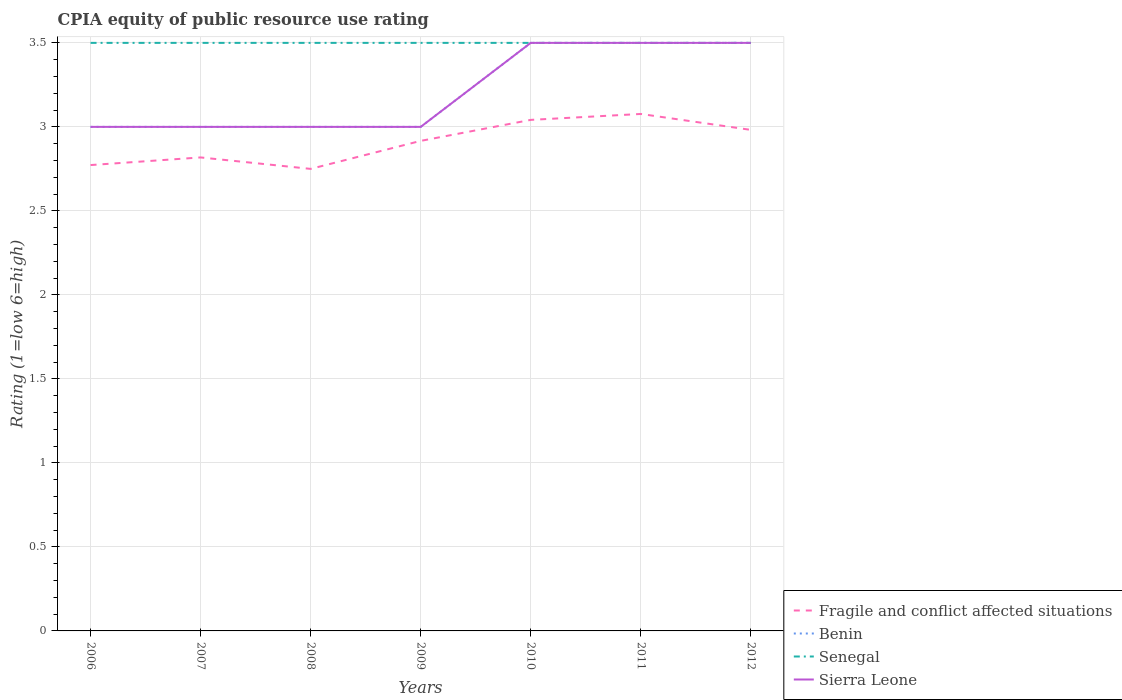Does the line corresponding to Sierra Leone intersect with the line corresponding to Senegal?
Your answer should be compact. Yes. What is the total CPIA rating in Fragile and conflict affected situations in the graph?
Keep it short and to the point. -0.27. What is the difference between the highest and the lowest CPIA rating in Senegal?
Provide a succinct answer. 0. Is the CPIA rating in Fragile and conflict affected situations strictly greater than the CPIA rating in Senegal over the years?
Give a very brief answer. Yes. How many lines are there?
Keep it short and to the point. 4. How many years are there in the graph?
Provide a succinct answer. 7. Are the values on the major ticks of Y-axis written in scientific E-notation?
Your response must be concise. No. Where does the legend appear in the graph?
Keep it short and to the point. Bottom right. How many legend labels are there?
Your answer should be compact. 4. How are the legend labels stacked?
Your answer should be very brief. Vertical. What is the title of the graph?
Ensure brevity in your answer.  CPIA equity of public resource use rating. What is the Rating (1=low 6=high) of Fragile and conflict affected situations in 2006?
Make the answer very short. 2.77. What is the Rating (1=low 6=high) in Benin in 2006?
Offer a terse response. 3. What is the Rating (1=low 6=high) in Sierra Leone in 2006?
Provide a succinct answer. 3. What is the Rating (1=low 6=high) of Fragile and conflict affected situations in 2007?
Keep it short and to the point. 2.82. What is the Rating (1=low 6=high) of Fragile and conflict affected situations in 2008?
Provide a succinct answer. 2.75. What is the Rating (1=low 6=high) in Benin in 2008?
Offer a very short reply. 3. What is the Rating (1=low 6=high) in Senegal in 2008?
Your answer should be very brief. 3.5. What is the Rating (1=low 6=high) in Sierra Leone in 2008?
Offer a terse response. 3. What is the Rating (1=low 6=high) in Fragile and conflict affected situations in 2009?
Provide a succinct answer. 2.92. What is the Rating (1=low 6=high) in Benin in 2009?
Your response must be concise. 3. What is the Rating (1=low 6=high) in Senegal in 2009?
Give a very brief answer. 3.5. What is the Rating (1=low 6=high) of Fragile and conflict affected situations in 2010?
Give a very brief answer. 3.04. What is the Rating (1=low 6=high) in Benin in 2010?
Give a very brief answer. 3.5. What is the Rating (1=low 6=high) of Senegal in 2010?
Your response must be concise. 3.5. What is the Rating (1=low 6=high) in Sierra Leone in 2010?
Provide a short and direct response. 3.5. What is the Rating (1=low 6=high) in Fragile and conflict affected situations in 2011?
Ensure brevity in your answer.  3.08. What is the Rating (1=low 6=high) of Benin in 2011?
Provide a succinct answer. 3.5. What is the Rating (1=low 6=high) in Senegal in 2011?
Keep it short and to the point. 3.5. What is the Rating (1=low 6=high) in Fragile and conflict affected situations in 2012?
Make the answer very short. 2.98. What is the Rating (1=low 6=high) of Benin in 2012?
Keep it short and to the point. 3.5. What is the Rating (1=low 6=high) in Senegal in 2012?
Offer a very short reply. 3.5. What is the Rating (1=low 6=high) in Sierra Leone in 2012?
Provide a short and direct response. 3.5. Across all years, what is the maximum Rating (1=low 6=high) in Fragile and conflict affected situations?
Keep it short and to the point. 3.08. Across all years, what is the maximum Rating (1=low 6=high) in Benin?
Offer a terse response. 3.5. Across all years, what is the maximum Rating (1=low 6=high) of Senegal?
Your answer should be very brief. 3.5. Across all years, what is the maximum Rating (1=low 6=high) in Sierra Leone?
Make the answer very short. 3.5. Across all years, what is the minimum Rating (1=low 6=high) in Fragile and conflict affected situations?
Keep it short and to the point. 2.75. Across all years, what is the minimum Rating (1=low 6=high) of Benin?
Give a very brief answer. 3. What is the total Rating (1=low 6=high) in Fragile and conflict affected situations in the graph?
Your answer should be very brief. 20.36. What is the total Rating (1=low 6=high) of Benin in the graph?
Your answer should be very brief. 22.5. What is the total Rating (1=low 6=high) in Senegal in the graph?
Your answer should be very brief. 24.5. What is the total Rating (1=low 6=high) in Sierra Leone in the graph?
Your response must be concise. 22.5. What is the difference between the Rating (1=low 6=high) in Fragile and conflict affected situations in 2006 and that in 2007?
Keep it short and to the point. -0.05. What is the difference between the Rating (1=low 6=high) of Senegal in 2006 and that in 2007?
Provide a short and direct response. 0. What is the difference between the Rating (1=low 6=high) of Sierra Leone in 2006 and that in 2007?
Ensure brevity in your answer.  0. What is the difference between the Rating (1=low 6=high) in Fragile and conflict affected situations in 2006 and that in 2008?
Your answer should be compact. 0.02. What is the difference between the Rating (1=low 6=high) in Benin in 2006 and that in 2008?
Ensure brevity in your answer.  0. What is the difference between the Rating (1=low 6=high) in Fragile and conflict affected situations in 2006 and that in 2009?
Provide a succinct answer. -0.14. What is the difference between the Rating (1=low 6=high) in Benin in 2006 and that in 2009?
Your answer should be very brief. 0. What is the difference between the Rating (1=low 6=high) of Sierra Leone in 2006 and that in 2009?
Offer a terse response. 0. What is the difference between the Rating (1=low 6=high) of Fragile and conflict affected situations in 2006 and that in 2010?
Your response must be concise. -0.27. What is the difference between the Rating (1=low 6=high) of Benin in 2006 and that in 2010?
Ensure brevity in your answer.  -0.5. What is the difference between the Rating (1=low 6=high) of Sierra Leone in 2006 and that in 2010?
Ensure brevity in your answer.  -0.5. What is the difference between the Rating (1=low 6=high) in Fragile and conflict affected situations in 2006 and that in 2011?
Offer a terse response. -0.3. What is the difference between the Rating (1=low 6=high) in Benin in 2006 and that in 2011?
Offer a very short reply. -0.5. What is the difference between the Rating (1=low 6=high) in Sierra Leone in 2006 and that in 2011?
Your response must be concise. -0.5. What is the difference between the Rating (1=low 6=high) of Fragile and conflict affected situations in 2006 and that in 2012?
Keep it short and to the point. -0.21. What is the difference between the Rating (1=low 6=high) in Benin in 2006 and that in 2012?
Give a very brief answer. -0.5. What is the difference between the Rating (1=low 6=high) in Senegal in 2006 and that in 2012?
Provide a succinct answer. 0. What is the difference between the Rating (1=low 6=high) of Sierra Leone in 2006 and that in 2012?
Provide a succinct answer. -0.5. What is the difference between the Rating (1=low 6=high) in Fragile and conflict affected situations in 2007 and that in 2008?
Your answer should be very brief. 0.07. What is the difference between the Rating (1=low 6=high) in Senegal in 2007 and that in 2008?
Offer a terse response. 0. What is the difference between the Rating (1=low 6=high) in Fragile and conflict affected situations in 2007 and that in 2009?
Ensure brevity in your answer.  -0.1. What is the difference between the Rating (1=low 6=high) of Benin in 2007 and that in 2009?
Keep it short and to the point. 0. What is the difference between the Rating (1=low 6=high) of Fragile and conflict affected situations in 2007 and that in 2010?
Your answer should be compact. -0.22. What is the difference between the Rating (1=low 6=high) of Benin in 2007 and that in 2010?
Your answer should be compact. -0.5. What is the difference between the Rating (1=low 6=high) in Fragile and conflict affected situations in 2007 and that in 2011?
Your answer should be compact. -0.26. What is the difference between the Rating (1=low 6=high) in Benin in 2007 and that in 2011?
Your answer should be very brief. -0.5. What is the difference between the Rating (1=low 6=high) of Sierra Leone in 2007 and that in 2011?
Offer a terse response. -0.5. What is the difference between the Rating (1=low 6=high) in Fragile and conflict affected situations in 2007 and that in 2012?
Your answer should be very brief. -0.16. What is the difference between the Rating (1=low 6=high) in Benin in 2007 and that in 2012?
Provide a succinct answer. -0.5. What is the difference between the Rating (1=low 6=high) of Senegal in 2007 and that in 2012?
Make the answer very short. 0. What is the difference between the Rating (1=low 6=high) of Sierra Leone in 2007 and that in 2012?
Give a very brief answer. -0.5. What is the difference between the Rating (1=low 6=high) of Fragile and conflict affected situations in 2008 and that in 2009?
Keep it short and to the point. -0.17. What is the difference between the Rating (1=low 6=high) of Benin in 2008 and that in 2009?
Your response must be concise. 0. What is the difference between the Rating (1=low 6=high) of Senegal in 2008 and that in 2009?
Your answer should be compact. 0. What is the difference between the Rating (1=low 6=high) of Sierra Leone in 2008 and that in 2009?
Provide a succinct answer. 0. What is the difference between the Rating (1=low 6=high) in Fragile and conflict affected situations in 2008 and that in 2010?
Keep it short and to the point. -0.29. What is the difference between the Rating (1=low 6=high) of Senegal in 2008 and that in 2010?
Offer a terse response. 0. What is the difference between the Rating (1=low 6=high) in Fragile and conflict affected situations in 2008 and that in 2011?
Offer a very short reply. -0.33. What is the difference between the Rating (1=low 6=high) of Benin in 2008 and that in 2011?
Provide a succinct answer. -0.5. What is the difference between the Rating (1=low 6=high) of Fragile and conflict affected situations in 2008 and that in 2012?
Your answer should be compact. -0.23. What is the difference between the Rating (1=low 6=high) of Benin in 2008 and that in 2012?
Make the answer very short. -0.5. What is the difference between the Rating (1=low 6=high) of Senegal in 2008 and that in 2012?
Provide a short and direct response. 0. What is the difference between the Rating (1=low 6=high) in Sierra Leone in 2008 and that in 2012?
Ensure brevity in your answer.  -0.5. What is the difference between the Rating (1=low 6=high) of Fragile and conflict affected situations in 2009 and that in 2010?
Your answer should be compact. -0.12. What is the difference between the Rating (1=low 6=high) of Benin in 2009 and that in 2010?
Provide a short and direct response. -0.5. What is the difference between the Rating (1=low 6=high) of Fragile and conflict affected situations in 2009 and that in 2011?
Ensure brevity in your answer.  -0.16. What is the difference between the Rating (1=low 6=high) in Sierra Leone in 2009 and that in 2011?
Ensure brevity in your answer.  -0.5. What is the difference between the Rating (1=low 6=high) of Fragile and conflict affected situations in 2009 and that in 2012?
Provide a succinct answer. -0.07. What is the difference between the Rating (1=low 6=high) of Benin in 2009 and that in 2012?
Your answer should be compact. -0.5. What is the difference between the Rating (1=low 6=high) of Senegal in 2009 and that in 2012?
Your answer should be very brief. 0. What is the difference between the Rating (1=low 6=high) of Sierra Leone in 2009 and that in 2012?
Ensure brevity in your answer.  -0.5. What is the difference between the Rating (1=low 6=high) of Fragile and conflict affected situations in 2010 and that in 2011?
Offer a terse response. -0.04. What is the difference between the Rating (1=low 6=high) in Benin in 2010 and that in 2011?
Offer a terse response. 0. What is the difference between the Rating (1=low 6=high) of Senegal in 2010 and that in 2011?
Make the answer very short. 0. What is the difference between the Rating (1=low 6=high) of Fragile and conflict affected situations in 2010 and that in 2012?
Your answer should be very brief. 0.06. What is the difference between the Rating (1=low 6=high) in Benin in 2010 and that in 2012?
Offer a very short reply. 0. What is the difference between the Rating (1=low 6=high) in Sierra Leone in 2010 and that in 2012?
Your answer should be very brief. 0. What is the difference between the Rating (1=low 6=high) of Fragile and conflict affected situations in 2011 and that in 2012?
Ensure brevity in your answer.  0.09. What is the difference between the Rating (1=low 6=high) of Benin in 2011 and that in 2012?
Provide a succinct answer. 0. What is the difference between the Rating (1=low 6=high) in Senegal in 2011 and that in 2012?
Make the answer very short. 0. What is the difference between the Rating (1=low 6=high) of Fragile and conflict affected situations in 2006 and the Rating (1=low 6=high) of Benin in 2007?
Keep it short and to the point. -0.23. What is the difference between the Rating (1=low 6=high) of Fragile and conflict affected situations in 2006 and the Rating (1=low 6=high) of Senegal in 2007?
Your response must be concise. -0.73. What is the difference between the Rating (1=low 6=high) of Fragile and conflict affected situations in 2006 and the Rating (1=low 6=high) of Sierra Leone in 2007?
Your response must be concise. -0.23. What is the difference between the Rating (1=low 6=high) of Fragile and conflict affected situations in 2006 and the Rating (1=low 6=high) of Benin in 2008?
Your response must be concise. -0.23. What is the difference between the Rating (1=low 6=high) of Fragile and conflict affected situations in 2006 and the Rating (1=low 6=high) of Senegal in 2008?
Provide a succinct answer. -0.73. What is the difference between the Rating (1=low 6=high) of Fragile and conflict affected situations in 2006 and the Rating (1=low 6=high) of Sierra Leone in 2008?
Offer a very short reply. -0.23. What is the difference between the Rating (1=low 6=high) of Senegal in 2006 and the Rating (1=low 6=high) of Sierra Leone in 2008?
Provide a succinct answer. 0.5. What is the difference between the Rating (1=low 6=high) of Fragile and conflict affected situations in 2006 and the Rating (1=low 6=high) of Benin in 2009?
Your answer should be compact. -0.23. What is the difference between the Rating (1=low 6=high) of Fragile and conflict affected situations in 2006 and the Rating (1=low 6=high) of Senegal in 2009?
Your answer should be compact. -0.73. What is the difference between the Rating (1=low 6=high) of Fragile and conflict affected situations in 2006 and the Rating (1=low 6=high) of Sierra Leone in 2009?
Your response must be concise. -0.23. What is the difference between the Rating (1=low 6=high) in Senegal in 2006 and the Rating (1=low 6=high) in Sierra Leone in 2009?
Provide a short and direct response. 0.5. What is the difference between the Rating (1=low 6=high) in Fragile and conflict affected situations in 2006 and the Rating (1=low 6=high) in Benin in 2010?
Provide a short and direct response. -0.73. What is the difference between the Rating (1=low 6=high) in Fragile and conflict affected situations in 2006 and the Rating (1=low 6=high) in Senegal in 2010?
Your answer should be compact. -0.73. What is the difference between the Rating (1=low 6=high) of Fragile and conflict affected situations in 2006 and the Rating (1=low 6=high) of Sierra Leone in 2010?
Offer a terse response. -0.73. What is the difference between the Rating (1=low 6=high) in Benin in 2006 and the Rating (1=low 6=high) in Senegal in 2010?
Your answer should be compact. -0.5. What is the difference between the Rating (1=low 6=high) in Benin in 2006 and the Rating (1=low 6=high) in Sierra Leone in 2010?
Offer a very short reply. -0.5. What is the difference between the Rating (1=low 6=high) in Senegal in 2006 and the Rating (1=low 6=high) in Sierra Leone in 2010?
Give a very brief answer. 0. What is the difference between the Rating (1=low 6=high) in Fragile and conflict affected situations in 2006 and the Rating (1=low 6=high) in Benin in 2011?
Provide a short and direct response. -0.73. What is the difference between the Rating (1=low 6=high) in Fragile and conflict affected situations in 2006 and the Rating (1=low 6=high) in Senegal in 2011?
Offer a terse response. -0.73. What is the difference between the Rating (1=low 6=high) of Fragile and conflict affected situations in 2006 and the Rating (1=low 6=high) of Sierra Leone in 2011?
Provide a succinct answer. -0.73. What is the difference between the Rating (1=low 6=high) in Benin in 2006 and the Rating (1=low 6=high) in Senegal in 2011?
Your answer should be very brief. -0.5. What is the difference between the Rating (1=low 6=high) in Benin in 2006 and the Rating (1=low 6=high) in Sierra Leone in 2011?
Provide a succinct answer. -0.5. What is the difference between the Rating (1=low 6=high) in Fragile and conflict affected situations in 2006 and the Rating (1=low 6=high) in Benin in 2012?
Provide a succinct answer. -0.73. What is the difference between the Rating (1=low 6=high) of Fragile and conflict affected situations in 2006 and the Rating (1=low 6=high) of Senegal in 2012?
Make the answer very short. -0.73. What is the difference between the Rating (1=low 6=high) in Fragile and conflict affected situations in 2006 and the Rating (1=low 6=high) in Sierra Leone in 2012?
Offer a terse response. -0.73. What is the difference between the Rating (1=low 6=high) of Benin in 2006 and the Rating (1=low 6=high) of Senegal in 2012?
Make the answer very short. -0.5. What is the difference between the Rating (1=low 6=high) of Fragile and conflict affected situations in 2007 and the Rating (1=low 6=high) of Benin in 2008?
Offer a terse response. -0.18. What is the difference between the Rating (1=low 6=high) of Fragile and conflict affected situations in 2007 and the Rating (1=low 6=high) of Senegal in 2008?
Ensure brevity in your answer.  -0.68. What is the difference between the Rating (1=low 6=high) of Fragile and conflict affected situations in 2007 and the Rating (1=low 6=high) of Sierra Leone in 2008?
Give a very brief answer. -0.18. What is the difference between the Rating (1=low 6=high) of Benin in 2007 and the Rating (1=low 6=high) of Sierra Leone in 2008?
Ensure brevity in your answer.  0. What is the difference between the Rating (1=low 6=high) of Fragile and conflict affected situations in 2007 and the Rating (1=low 6=high) of Benin in 2009?
Offer a terse response. -0.18. What is the difference between the Rating (1=low 6=high) of Fragile and conflict affected situations in 2007 and the Rating (1=low 6=high) of Senegal in 2009?
Provide a short and direct response. -0.68. What is the difference between the Rating (1=low 6=high) in Fragile and conflict affected situations in 2007 and the Rating (1=low 6=high) in Sierra Leone in 2009?
Your response must be concise. -0.18. What is the difference between the Rating (1=low 6=high) in Senegal in 2007 and the Rating (1=low 6=high) in Sierra Leone in 2009?
Your answer should be very brief. 0.5. What is the difference between the Rating (1=low 6=high) in Fragile and conflict affected situations in 2007 and the Rating (1=low 6=high) in Benin in 2010?
Your answer should be very brief. -0.68. What is the difference between the Rating (1=low 6=high) of Fragile and conflict affected situations in 2007 and the Rating (1=low 6=high) of Senegal in 2010?
Provide a succinct answer. -0.68. What is the difference between the Rating (1=low 6=high) of Fragile and conflict affected situations in 2007 and the Rating (1=low 6=high) of Sierra Leone in 2010?
Your response must be concise. -0.68. What is the difference between the Rating (1=low 6=high) of Benin in 2007 and the Rating (1=low 6=high) of Senegal in 2010?
Your answer should be very brief. -0.5. What is the difference between the Rating (1=low 6=high) in Benin in 2007 and the Rating (1=low 6=high) in Sierra Leone in 2010?
Offer a very short reply. -0.5. What is the difference between the Rating (1=low 6=high) of Fragile and conflict affected situations in 2007 and the Rating (1=low 6=high) of Benin in 2011?
Ensure brevity in your answer.  -0.68. What is the difference between the Rating (1=low 6=high) of Fragile and conflict affected situations in 2007 and the Rating (1=low 6=high) of Senegal in 2011?
Offer a terse response. -0.68. What is the difference between the Rating (1=low 6=high) of Fragile and conflict affected situations in 2007 and the Rating (1=low 6=high) of Sierra Leone in 2011?
Provide a succinct answer. -0.68. What is the difference between the Rating (1=low 6=high) of Benin in 2007 and the Rating (1=low 6=high) of Sierra Leone in 2011?
Your answer should be compact. -0.5. What is the difference between the Rating (1=low 6=high) in Fragile and conflict affected situations in 2007 and the Rating (1=low 6=high) in Benin in 2012?
Provide a short and direct response. -0.68. What is the difference between the Rating (1=low 6=high) of Fragile and conflict affected situations in 2007 and the Rating (1=low 6=high) of Senegal in 2012?
Keep it short and to the point. -0.68. What is the difference between the Rating (1=low 6=high) of Fragile and conflict affected situations in 2007 and the Rating (1=low 6=high) of Sierra Leone in 2012?
Keep it short and to the point. -0.68. What is the difference between the Rating (1=low 6=high) in Benin in 2007 and the Rating (1=low 6=high) in Sierra Leone in 2012?
Make the answer very short. -0.5. What is the difference between the Rating (1=low 6=high) in Senegal in 2007 and the Rating (1=low 6=high) in Sierra Leone in 2012?
Your response must be concise. 0. What is the difference between the Rating (1=low 6=high) in Fragile and conflict affected situations in 2008 and the Rating (1=low 6=high) in Benin in 2009?
Your response must be concise. -0.25. What is the difference between the Rating (1=low 6=high) of Fragile and conflict affected situations in 2008 and the Rating (1=low 6=high) of Senegal in 2009?
Make the answer very short. -0.75. What is the difference between the Rating (1=low 6=high) in Fragile and conflict affected situations in 2008 and the Rating (1=low 6=high) in Benin in 2010?
Offer a very short reply. -0.75. What is the difference between the Rating (1=low 6=high) of Fragile and conflict affected situations in 2008 and the Rating (1=low 6=high) of Senegal in 2010?
Provide a succinct answer. -0.75. What is the difference between the Rating (1=low 6=high) in Fragile and conflict affected situations in 2008 and the Rating (1=low 6=high) in Sierra Leone in 2010?
Keep it short and to the point. -0.75. What is the difference between the Rating (1=low 6=high) of Fragile and conflict affected situations in 2008 and the Rating (1=low 6=high) of Benin in 2011?
Offer a terse response. -0.75. What is the difference between the Rating (1=low 6=high) in Fragile and conflict affected situations in 2008 and the Rating (1=low 6=high) in Senegal in 2011?
Ensure brevity in your answer.  -0.75. What is the difference between the Rating (1=low 6=high) in Fragile and conflict affected situations in 2008 and the Rating (1=low 6=high) in Sierra Leone in 2011?
Provide a succinct answer. -0.75. What is the difference between the Rating (1=low 6=high) in Senegal in 2008 and the Rating (1=low 6=high) in Sierra Leone in 2011?
Give a very brief answer. 0. What is the difference between the Rating (1=low 6=high) in Fragile and conflict affected situations in 2008 and the Rating (1=low 6=high) in Benin in 2012?
Make the answer very short. -0.75. What is the difference between the Rating (1=low 6=high) of Fragile and conflict affected situations in 2008 and the Rating (1=low 6=high) of Senegal in 2012?
Keep it short and to the point. -0.75. What is the difference between the Rating (1=low 6=high) in Fragile and conflict affected situations in 2008 and the Rating (1=low 6=high) in Sierra Leone in 2012?
Offer a terse response. -0.75. What is the difference between the Rating (1=low 6=high) in Benin in 2008 and the Rating (1=low 6=high) in Senegal in 2012?
Offer a terse response. -0.5. What is the difference between the Rating (1=low 6=high) of Fragile and conflict affected situations in 2009 and the Rating (1=low 6=high) of Benin in 2010?
Your response must be concise. -0.58. What is the difference between the Rating (1=low 6=high) in Fragile and conflict affected situations in 2009 and the Rating (1=low 6=high) in Senegal in 2010?
Offer a terse response. -0.58. What is the difference between the Rating (1=low 6=high) of Fragile and conflict affected situations in 2009 and the Rating (1=low 6=high) of Sierra Leone in 2010?
Provide a short and direct response. -0.58. What is the difference between the Rating (1=low 6=high) in Benin in 2009 and the Rating (1=low 6=high) in Senegal in 2010?
Give a very brief answer. -0.5. What is the difference between the Rating (1=low 6=high) in Benin in 2009 and the Rating (1=low 6=high) in Sierra Leone in 2010?
Your answer should be compact. -0.5. What is the difference between the Rating (1=low 6=high) in Fragile and conflict affected situations in 2009 and the Rating (1=low 6=high) in Benin in 2011?
Ensure brevity in your answer.  -0.58. What is the difference between the Rating (1=low 6=high) in Fragile and conflict affected situations in 2009 and the Rating (1=low 6=high) in Senegal in 2011?
Keep it short and to the point. -0.58. What is the difference between the Rating (1=low 6=high) of Fragile and conflict affected situations in 2009 and the Rating (1=low 6=high) of Sierra Leone in 2011?
Your answer should be very brief. -0.58. What is the difference between the Rating (1=low 6=high) of Senegal in 2009 and the Rating (1=low 6=high) of Sierra Leone in 2011?
Offer a very short reply. 0. What is the difference between the Rating (1=low 6=high) of Fragile and conflict affected situations in 2009 and the Rating (1=low 6=high) of Benin in 2012?
Offer a very short reply. -0.58. What is the difference between the Rating (1=low 6=high) in Fragile and conflict affected situations in 2009 and the Rating (1=low 6=high) in Senegal in 2012?
Offer a very short reply. -0.58. What is the difference between the Rating (1=low 6=high) of Fragile and conflict affected situations in 2009 and the Rating (1=low 6=high) of Sierra Leone in 2012?
Keep it short and to the point. -0.58. What is the difference between the Rating (1=low 6=high) in Benin in 2009 and the Rating (1=low 6=high) in Senegal in 2012?
Provide a succinct answer. -0.5. What is the difference between the Rating (1=low 6=high) in Benin in 2009 and the Rating (1=low 6=high) in Sierra Leone in 2012?
Keep it short and to the point. -0.5. What is the difference between the Rating (1=low 6=high) in Senegal in 2009 and the Rating (1=low 6=high) in Sierra Leone in 2012?
Your answer should be compact. 0. What is the difference between the Rating (1=low 6=high) of Fragile and conflict affected situations in 2010 and the Rating (1=low 6=high) of Benin in 2011?
Give a very brief answer. -0.46. What is the difference between the Rating (1=low 6=high) of Fragile and conflict affected situations in 2010 and the Rating (1=low 6=high) of Senegal in 2011?
Your answer should be very brief. -0.46. What is the difference between the Rating (1=low 6=high) in Fragile and conflict affected situations in 2010 and the Rating (1=low 6=high) in Sierra Leone in 2011?
Your answer should be very brief. -0.46. What is the difference between the Rating (1=low 6=high) of Benin in 2010 and the Rating (1=low 6=high) of Senegal in 2011?
Provide a succinct answer. 0. What is the difference between the Rating (1=low 6=high) of Senegal in 2010 and the Rating (1=low 6=high) of Sierra Leone in 2011?
Give a very brief answer. 0. What is the difference between the Rating (1=low 6=high) of Fragile and conflict affected situations in 2010 and the Rating (1=low 6=high) of Benin in 2012?
Make the answer very short. -0.46. What is the difference between the Rating (1=low 6=high) of Fragile and conflict affected situations in 2010 and the Rating (1=low 6=high) of Senegal in 2012?
Give a very brief answer. -0.46. What is the difference between the Rating (1=low 6=high) of Fragile and conflict affected situations in 2010 and the Rating (1=low 6=high) of Sierra Leone in 2012?
Make the answer very short. -0.46. What is the difference between the Rating (1=low 6=high) in Benin in 2010 and the Rating (1=low 6=high) in Senegal in 2012?
Provide a succinct answer. 0. What is the difference between the Rating (1=low 6=high) in Senegal in 2010 and the Rating (1=low 6=high) in Sierra Leone in 2012?
Your response must be concise. 0. What is the difference between the Rating (1=low 6=high) of Fragile and conflict affected situations in 2011 and the Rating (1=low 6=high) of Benin in 2012?
Keep it short and to the point. -0.42. What is the difference between the Rating (1=low 6=high) of Fragile and conflict affected situations in 2011 and the Rating (1=low 6=high) of Senegal in 2012?
Give a very brief answer. -0.42. What is the difference between the Rating (1=low 6=high) in Fragile and conflict affected situations in 2011 and the Rating (1=low 6=high) in Sierra Leone in 2012?
Provide a succinct answer. -0.42. What is the average Rating (1=low 6=high) in Fragile and conflict affected situations per year?
Ensure brevity in your answer.  2.91. What is the average Rating (1=low 6=high) in Benin per year?
Your answer should be compact. 3.21. What is the average Rating (1=low 6=high) of Senegal per year?
Provide a short and direct response. 3.5. What is the average Rating (1=low 6=high) in Sierra Leone per year?
Keep it short and to the point. 3.21. In the year 2006, what is the difference between the Rating (1=low 6=high) of Fragile and conflict affected situations and Rating (1=low 6=high) of Benin?
Provide a succinct answer. -0.23. In the year 2006, what is the difference between the Rating (1=low 6=high) in Fragile and conflict affected situations and Rating (1=low 6=high) in Senegal?
Offer a very short reply. -0.73. In the year 2006, what is the difference between the Rating (1=low 6=high) in Fragile and conflict affected situations and Rating (1=low 6=high) in Sierra Leone?
Provide a short and direct response. -0.23. In the year 2007, what is the difference between the Rating (1=low 6=high) in Fragile and conflict affected situations and Rating (1=low 6=high) in Benin?
Your response must be concise. -0.18. In the year 2007, what is the difference between the Rating (1=low 6=high) of Fragile and conflict affected situations and Rating (1=low 6=high) of Senegal?
Provide a succinct answer. -0.68. In the year 2007, what is the difference between the Rating (1=low 6=high) of Fragile and conflict affected situations and Rating (1=low 6=high) of Sierra Leone?
Your answer should be compact. -0.18. In the year 2007, what is the difference between the Rating (1=low 6=high) of Benin and Rating (1=low 6=high) of Senegal?
Keep it short and to the point. -0.5. In the year 2007, what is the difference between the Rating (1=low 6=high) of Benin and Rating (1=low 6=high) of Sierra Leone?
Your response must be concise. 0. In the year 2007, what is the difference between the Rating (1=low 6=high) in Senegal and Rating (1=low 6=high) in Sierra Leone?
Offer a very short reply. 0.5. In the year 2008, what is the difference between the Rating (1=low 6=high) of Fragile and conflict affected situations and Rating (1=low 6=high) of Benin?
Your response must be concise. -0.25. In the year 2008, what is the difference between the Rating (1=low 6=high) of Fragile and conflict affected situations and Rating (1=low 6=high) of Senegal?
Provide a short and direct response. -0.75. In the year 2008, what is the difference between the Rating (1=low 6=high) in Fragile and conflict affected situations and Rating (1=low 6=high) in Sierra Leone?
Your answer should be compact. -0.25. In the year 2009, what is the difference between the Rating (1=low 6=high) in Fragile and conflict affected situations and Rating (1=low 6=high) in Benin?
Your answer should be very brief. -0.08. In the year 2009, what is the difference between the Rating (1=low 6=high) in Fragile and conflict affected situations and Rating (1=low 6=high) in Senegal?
Offer a very short reply. -0.58. In the year 2009, what is the difference between the Rating (1=low 6=high) in Fragile and conflict affected situations and Rating (1=low 6=high) in Sierra Leone?
Provide a succinct answer. -0.08. In the year 2009, what is the difference between the Rating (1=low 6=high) of Senegal and Rating (1=low 6=high) of Sierra Leone?
Provide a short and direct response. 0.5. In the year 2010, what is the difference between the Rating (1=low 6=high) of Fragile and conflict affected situations and Rating (1=low 6=high) of Benin?
Provide a succinct answer. -0.46. In the year 2010, what is the difference between the Rating (1=low 6=high) of Fragile and conflict affected situations and Rating (1=low 6=high) of Senegal?
Keep it short and to the point. -0.46. In the year 2010, what is the difference between the Rating (1=low 6=high) of Fragile and conflict affected situations and Rating (1=low 6=high) of Sierra Leone?
Ensure brevity in your answer.  -0.46. In the year 2010, what is the difference between the Rating (1=low 6=high) of Benin and Rating (1=low 6=high) of Senegal?
Provide a short and direct response. 0. In the year 2011, what is the difference between the Rating (1=low 6=high) in Fragile and conflict affected situations and Rating (1=low 6=high) in Benin?
Your response must be concise. -0.42. In the year 2011, what is the difference between the Rating (1=low 6=high) of Fragile and conflict affected situations and Rating (1=low 6=high) of Senegal?
Your response must be concise. -0.42. In the year 2011, what is the difference between the Rating (1=low 6=high) of Fragile and conflict affected situations and Rating (1=low 6=high) of Sierra Leone?
Provide a short and direct response. -0.42. In the year 2011, what is the difference between the Rating (1=low 6=high) in Benin and Rating (1=low 6=high) in Senegal?
Give a very brief answer. 0. In the year 2012, what is the difference between the Rating (1=low 6=high) in Fragile and conflict affected situations and Rating (1=low 6=high) in Benin?
Provide a succinct answer. -0.52. In the year 2012, what is the difference between the Rating (1=low 6=high) in Fragile and conflict affected situations and Rating (1=low 6=high) in Senegal?
Your response must be concise. -0.52. In the year 2012, what is the difference between the Rating (1=low 6=high) of Fragile and conflict affected situations and Rating (1=low 6=high) of Sierra Leone?
Ensure brevity in your answer.  -0.52. In the year 2012, what is the difference between the Rating (1=low 6=high) in Benin and Rating (1=low 6=high) in Senegal?
Offer a terse response. 0. In the year 2012, what is the difference between the Rating (1=low 6=high) in Benin and Rating (1=low 6=high) in Sierra Leone?
Offer a terse response. 0. In the year 2012, what is the difference between the Rating (1=low 6=high) of Senegal and Rating (1=low 6=high) of Sierra Leone?
Offer a terse response. 0. What is the ratio of the Rating (1=low 6=high) in Fragile and conflict affected situations in 2006 to that in 2007?
Give a very brief answer. 0.98. What is the ratio of the Rating (1=low 6=high) in Senegal in 2006 to that in 2007?
Provide a short and direct response. 1. What is the ratio of the Rating (1=low 6=high) of Fragile and conflict affected situations in 2006 to that in 2008?
Give a very brief answer. 1.01. What is the ratio of the Rating (1=low 6=high) in Benin in 2006 to that in 2008?
Provide a short and direct response. 1. What is the ratio of the Rating (1=low 6=high) of Senegal in 2006 to that in 2008?
Give a very brief answer. 1. What is the ratio of the Rating (1=low 6=high) in Fragile and conflict affected situations in 2006 to that in 2009?
Ensure brevity in your answer.  0.95. What is the ratio of the Rating (1=low 6=high) of Sierra Leone in 2006 to that in 2009?
Your response must be concise. 1. What is the ratio of the Rating (1=low 6=high) of Fragile and conflict affected situations in 2006 to that in 2010?
Offer a terse response. 0.91. What is the ratio of the Rating (1=low 6=high) in Fragile and conflict affected situations in 2006 to that in 2011?
Provide a succinct answer. 0.9. What is the ratio of the Rating (1=low 6=high) of Benin in 2006 to that in 2011?
Your answer should be very brief. 0.86. What is the ratio of the Rating (1=low 6=high) of Senegal in 2006 to that in 2011?
Your response must be concise. 1. What is the ratio of the Rating (1=low 6=high) of Sierra Leone in 2006 to that in 2011?
Ensure brevity in your answer.  0.86. What is the ratio of the Rating (1=low 6=high) of Fragile and conflict affected situations in 2006 to that in 2012?
Make the answer very short. 0.93. What is the ratio of the Rating (1=low 6=high) in Benin in 2006 to that in 2012?
Make the answer very short. 0.86. What is the ratio of the Rating (1=low 6=high) of Sierra Leone in 2006 to that in 2012?
Your answer should be very brief. 0.86. What is the ratio of the Rating (1=low 6=high) of Fragile and conflict affected situations in 2007 to that in 2008?
Make the answer very short. 1.02. What is the ratio of the Rating (1=low 6=high) of Benin in 2007 to that in 2008?
Offer a terse response. 1. What is the ratio of the Rating (1=low 6=high) in Fragile and conflict affected situations in 2007 to that in 2009?
Offer a very short reply. 0.97. What is the ratio of the Rating (1=low 6=high) of Senegal in 2007 to that in 2009?
Offer a terse response. 1. What is the ratio of the Rating (1=low 6=high) in Fragile and conflict affected situations in 2007 to that in 2010?
Offer a very short reply. 0.93. What is the ratio of the Rating (1=low 6=high) of Benin in 2007 to that in 2010?
Your answer should be compact. 0.86. What is the ratio of the Rating (1=low 6=high) in Sierra Leone in 2007 to that in 2010?
Offer a terse response. 0.86. What is the ratio of the Rating (1=low 6=high) in Fragile and conflict affected situations in 2007 to that in 2011?
Provide a short and direct response. 0.92. What is the ratio of the Rating (1=low 6=high) in Senegal in 2007 to that in 2011?
Offer a very short reply. 1. What is the ratio of the Rating (1=low 6=high) of Fragile and conflict affected situations in 2007 to that in 2012?
Give a very brief answer. 0.94. What is the ratio of the Rating (1=low 6=high) in Senegal in 2007 to that in 2012?
Offer a very short reply. 1. What is the ratio of the Rating (1=low 6=high) in Fragile and conflict affected situations in 2008 to that in 2009?
Ensure brevity in your answer.  0.94. What is the ratio of the Rating (1=low 6=high) in Benin in 2008 to that in 2009?
Your response must be concise. 1. What is the ratio of the Rating (1=low 6=high) in Senegal in 2008 to that in 2009?
Provide a succinct answer. 1. What is the ratio of the Rating (1=low 6=high) in Fragile and conflict affected situations in 2008 to that in 2010?
Offer a terse response. 0.9. What is the ratio of the Rating (1=low 6=high) of Benin in 2008 to that in 2010?
Provide a succinct answer. 0.86. What is the ratio of the Rating (1=low 6=high) in Senegal in 2008 to that in 2010?
Ensure brevity in your answer.  1. What is the ratio of the Rating (1=low 6=high) in Sierra Leone in 2008 to that in 2010?
Give a very brief answer. 0.86. What is the ratio of the Rating (1=low 6=high) in Fragile and conflict affected situations in 2008 to that in 2011?
Offer a terse response. 0.89. What is the ratio of the Rating (1=low 6=high) in Senegal in 2008 to that in 2011?
Your response must be concise. 1. What is the ratio of the Rating (1=low 6=high) in Sierra Leone in 2008 to that in 2011?
Provide a succinct answer. 0.86. What is the ratio of the Rating (1=low 6=high) of Fragile and conflict affected situations in 2008 to that in 2012?
Provide a succinct answer. 0.92. What is the ratio of the Rating (1=low 6=high) in Benin in 2008 to that in 2012?
Your answer should be very brief. 0.86. What is the ratio of the Rating (1=low 6=high) in Fragile and conflict affected situations in 2009 to that in 2010?
Offer a very short reply. 0.96. What is the ratio of the Rating (1=low 6=high) in Sierra Leone in 2009 to that in 2010?
Offer a very short reply. 0.86. What is the ratio of the Rating (1=low 6=high) in Fragile and conflict affected situations in 2009 to that in 2011?
Give a very brief answer. 0.95. What is the ratio of the Rating (1=low 6=high) of Benin in 2009 to that in 2011?
Your response must be concise. 0.86. What is the ratio of the Rating (1=low 6=high) in Senegal in 2010 to that in 2011?
Offer a terse response. 1. What is the ratio of the Rating (1=low 6=high) of Fragile and conflict affected situations in 2010 to that in 2012?
Your response must be concise. 1.02. What is the ratio of the Rating (1=low 6=high) in Benin in 2010 to that in 2012?
Keep it short and to the point. 1. What is the ratio of the Rating (1=low 6=high) in Fragile and conflict affected situations in 2011 to that in 2012?
Provide a succinct answer. 1.03. What is the ratio of the Rating (1=low 6=high) of Senegal in 2011 to that in 2012?
Make the answer very short. 1. What is the difference between the highest and the second highest Rating (1=low 6=high) of Fragile and conflict affected situations?
Offer a very short reply. 0.04. What is the difference between the highest and the second highest Rating (1=low 6=high) of Senegal?
Keep it short and to the point. 0. What is the difference between the highest and the second highest Rating (1=low 6=high) of Sierra Leone?
Your answer should be compact. 0. What is the difference between the highest and the lowest Rating (1=low 6=high) of Fragile and conflict affected situations?
Provide a succinct answer. 0.33. What is the difference between the highest and the lowest Rating (1=low 6=high) of Senegal?
Provide a succinct answer. 0. What is the difference between the highest and the lowest Rating (1=low 6=high) in Sierra Leone?
Offer a terse response. 0.5. 